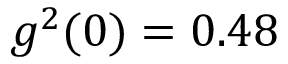Convert formula to latex. <formula><loc_0><loc_0><loc_500><loc_500>g ^ { 2 } ( 0 ) = 0 . 4 8</formula> 